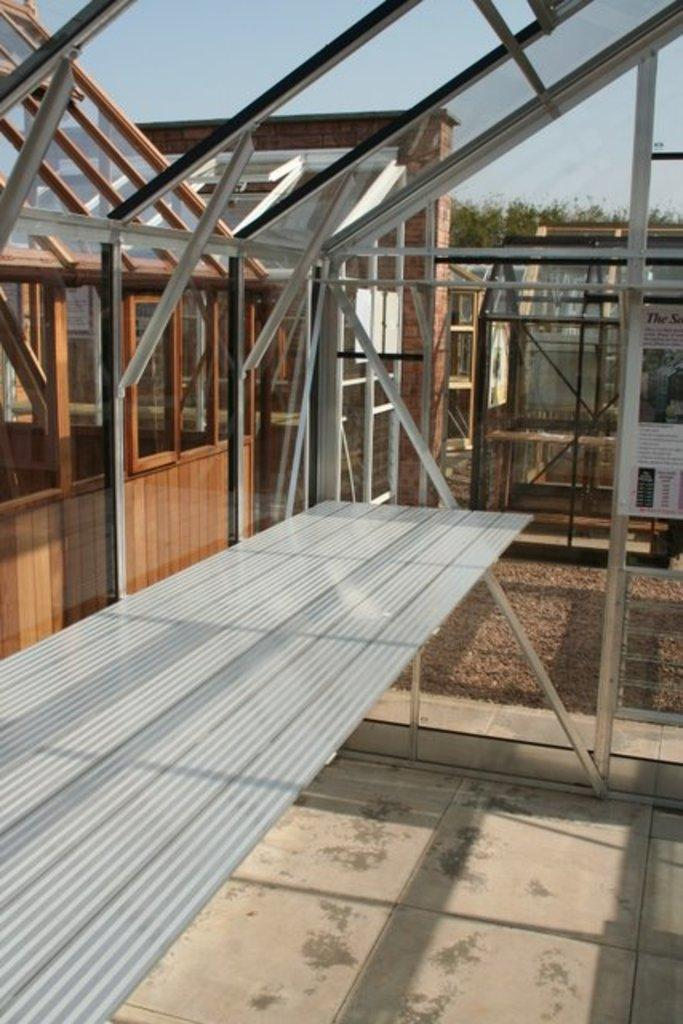What type of construction material is visible in the image? There are roof sheets in the image. What surface can be seen beneath the roof sheets? There is a floor visible in the image. What allows light and air into the structure in the image? There are windows in the image. What type of transportation infrastructure is present in the image? There are roads in the image. What type of vegetation is present in the image? There are trees in the image. What can be seen in the distance in the image? The sky is visible in the background of the image. Where can the note be found in the image? There is no note present in the image. How many rabbits can be seen playing in the alley in the image? There is no alley or rabbits present in the image. 